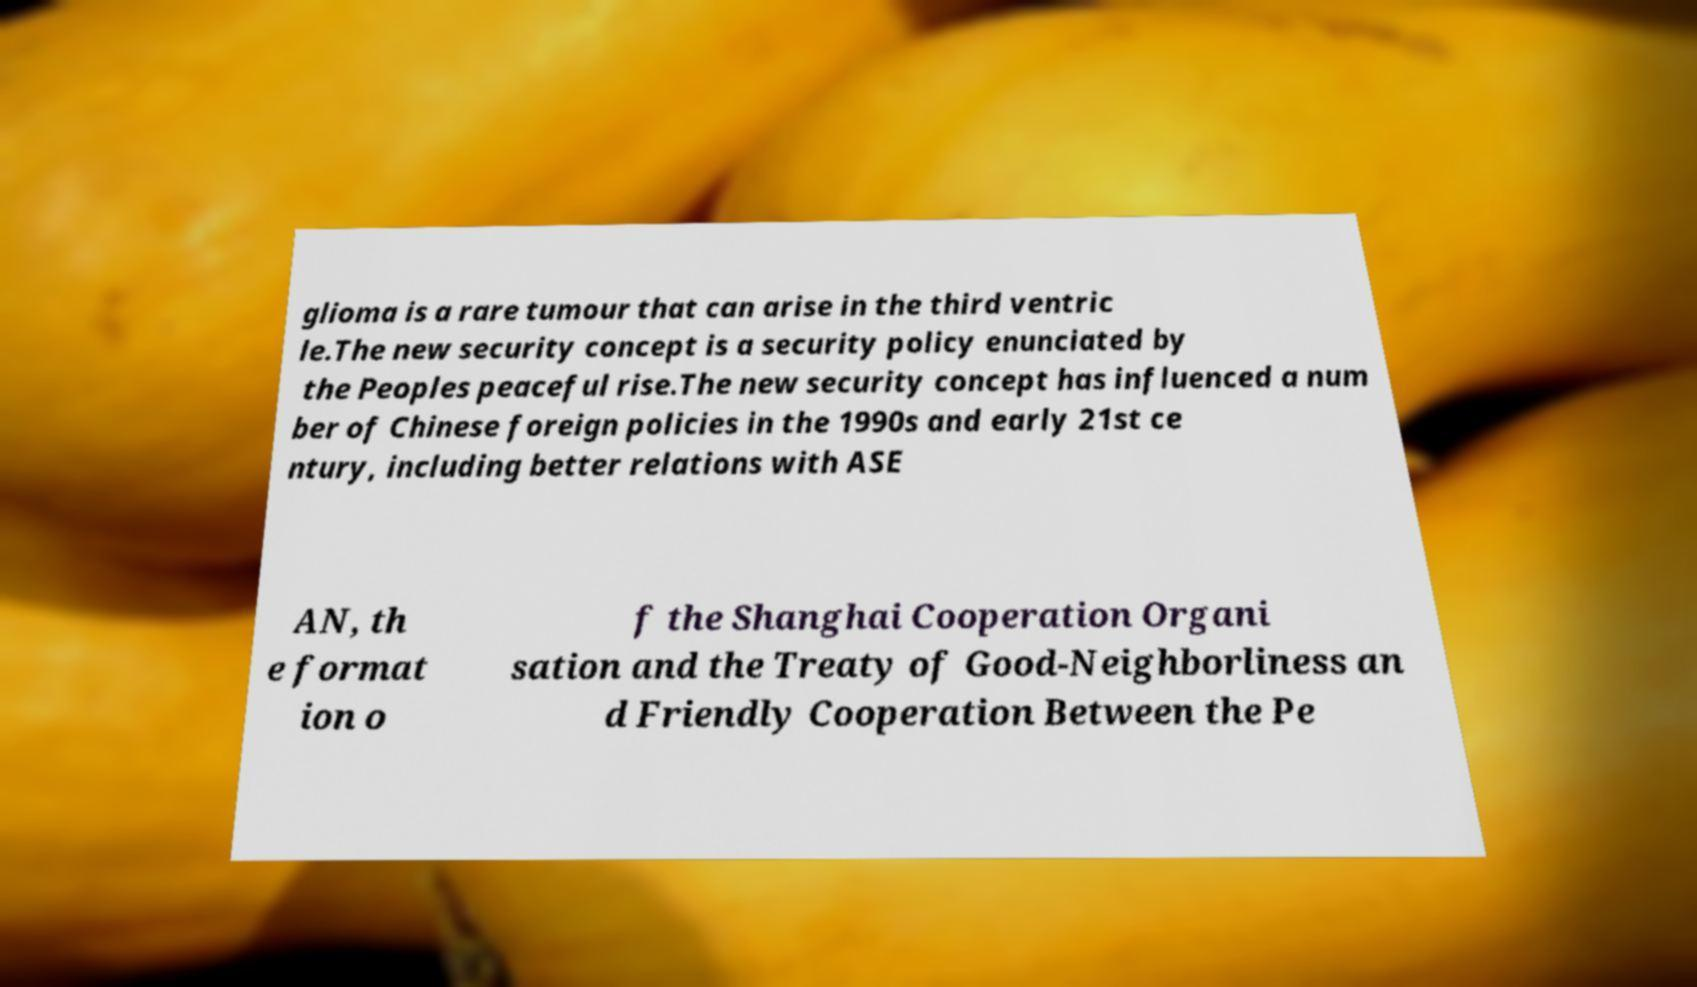There's text embedded in this image that I need extracted. Can you transcribe it verbatim? glioma is a rare tumour that can arise in the third ventric le.The new security concept is a security policy enunciated by the Peoples peaceful rise.The new security concept has influenced a num ber of Chinese foreign policies in the 1990s and early 21st ce ntury, including better relations with ASE AN, th e format ion o f the Shanghai Cooperation Organi sation and the Treaty of Good-Neighborliness an d Friendly Cooperation Between the Pe 